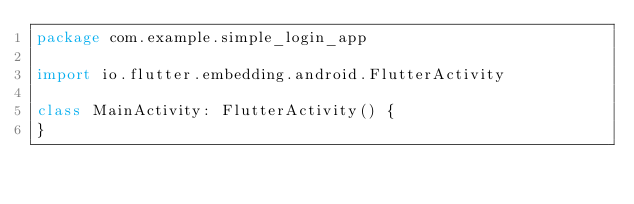<code> <loc_0><loc_0><loc_500><loc_500><_Kotlin_>package com.example.simple_login_app

import io.flutter.embedding.android.FlutterActivity

class MainActivity: FlutterActivity() {
}
</code> 